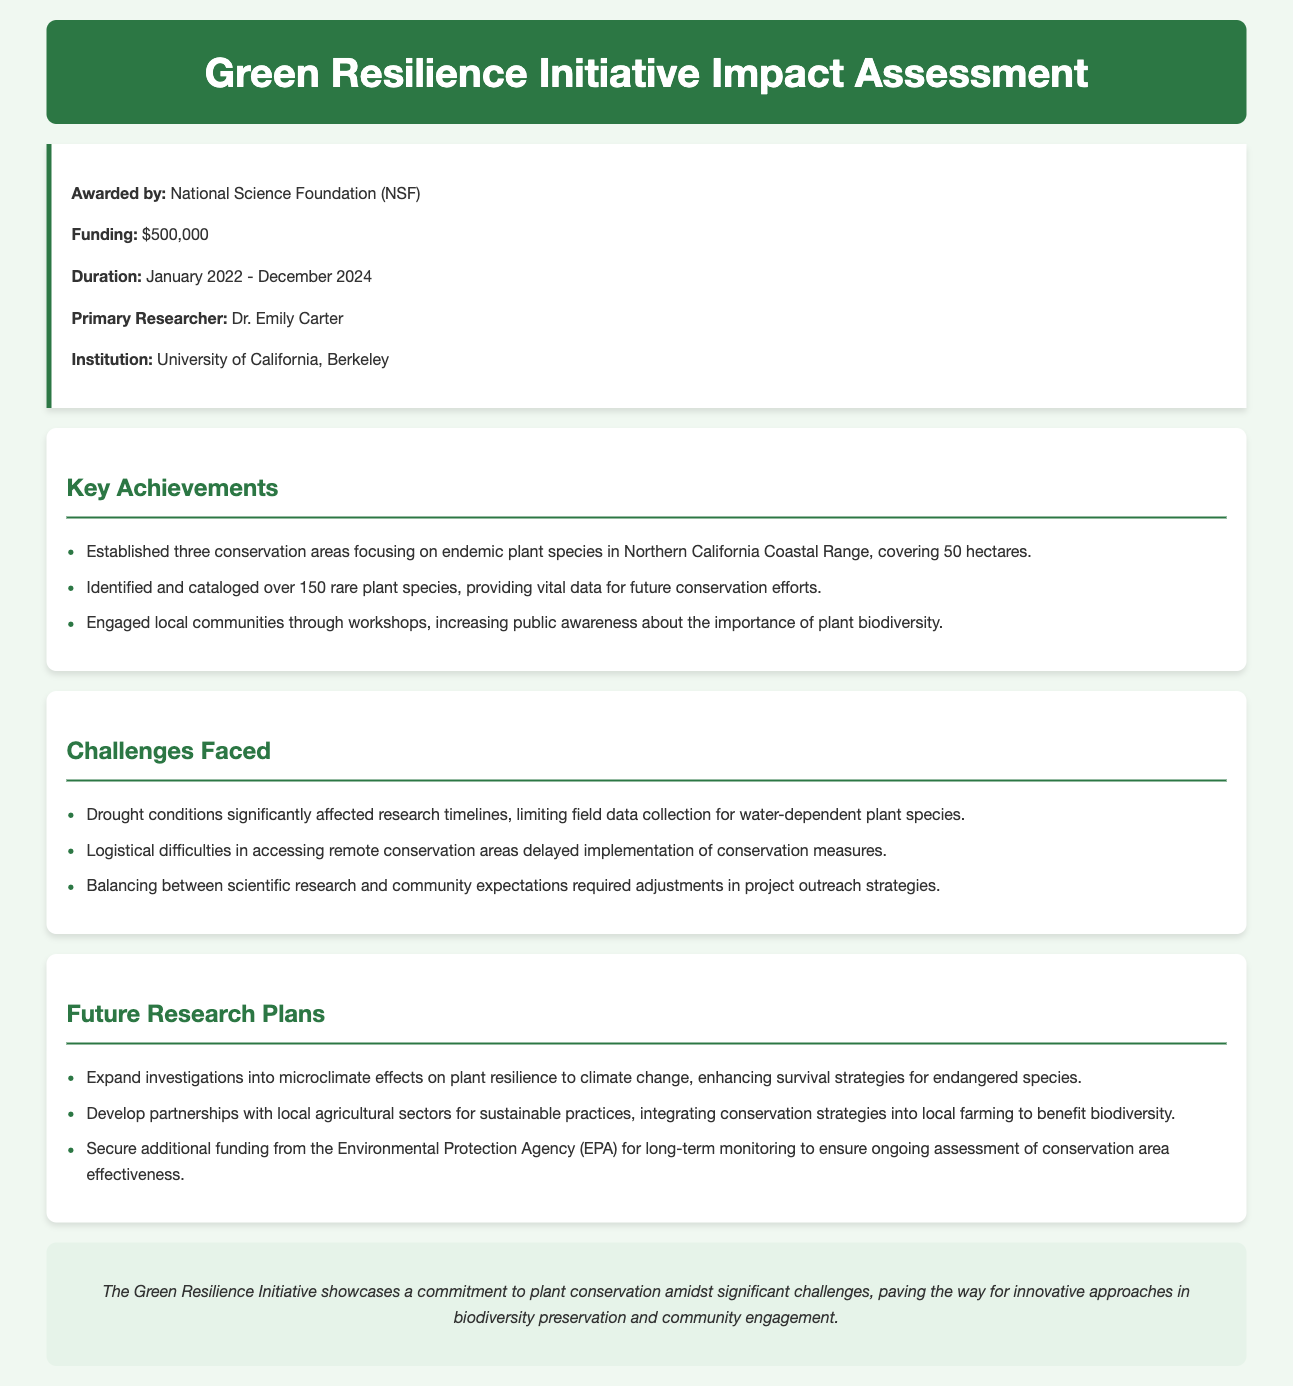What is the grant amount? The grant amount is specified in the document under funding, which is $500,000.
Answer: $500,000 Who is the primary researcher of the project? The primary researcher is mentioned in the grant details section as Dr. Emily Carter.
Answer: Dr. Emily Carter What duration does the grant cover? The duration is indicated in the grant details section, stating January 2022 - December 2024.
Answer: January 2022 - December 2024 How many conservation areas were established? The key achievements section states that three conservation areas were established.
Answer: three What challenge impacted research timelines? The challenges faced indicates that drought conditions significantly affected research timelines.
Answer: drought conditions What is one future research plan mentioned? The future research plans outline several initiatives, one being expanding investigations into microclimate effects on plant resilience.
Answer: expand investigations into microclimate effects on plant resilience Which funding agency awarded the grant? The grant details specify the awarding agency as the National Science Foundation (NSF).
Answer: National Science Foundation (NSF) What is the main goal of the Green Resilience Initiative? The conclusion summarizes the initiative's goal as a commitment to plant conservation amidst challenges.
Answer: commitment to plant conservation What outreach strategy adjustment was made? The challenges faced section mentions that balancing scientific research and community expectations required adjustments in project outreach strategies.
Answer: adjustments in project outreach strategies 